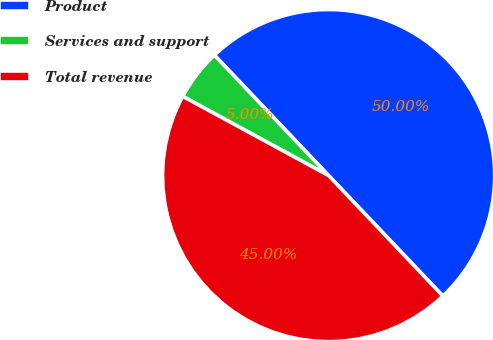Convert chart to OTSL. <chart><loc_0><loc_0><loc_500><loc_500><pie_chart><fcel>Product<fcel>Services and support<fcel>Total revenue<nl><fcel>50.0%<fcel>5.0%<fcel>45.0%<nl></chart> 